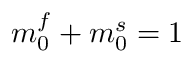Convert formula to latex. <formula><loc_0><loc_0><loc_500><loc_500>m _ { 0 } ^ { f } + m _ { 0 } ^ { s } = 1</formula> 